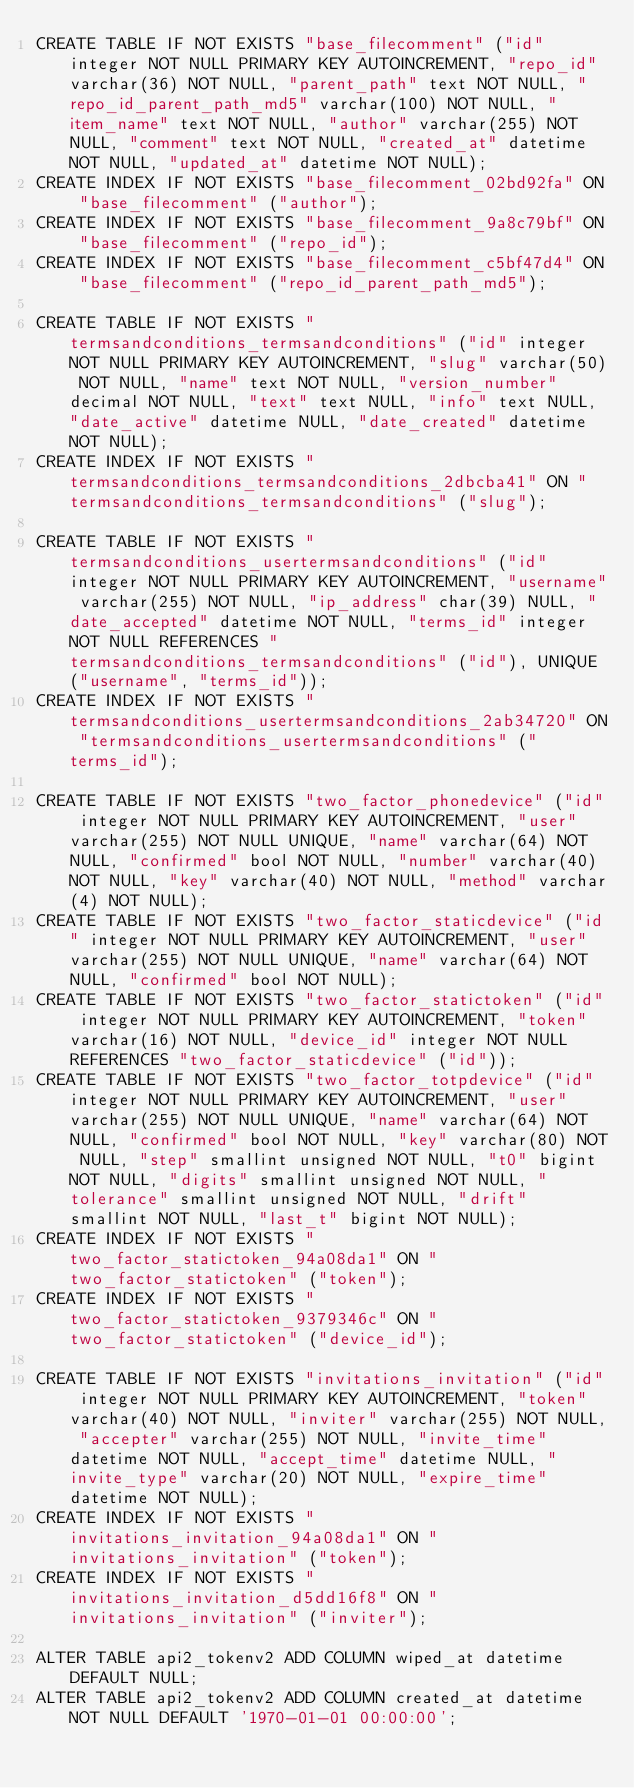Convert code to text. <code><loc_0><loc_0><loc_500><loc_500><_SQL_>CREATE TABLE IF NOT EXISTS "base_filecomment" ("id" integer NOT NULL PRIMARY KEY AUTOINCREMENT, "repo_id" varchar(36) NOT NULL, "parent_path" text NOT NULL, "repo_id_parent_path_md5" varchar(100) NOT NULL, "item_name" text NOT NULL, "author" varchar(255) NOT NULL, "comment" text NOT NULL, "created_at" datetime NOT NULL, "updated_at" datetime NOT NULL);
CREATE INDEX IF NOT EXISTS "base_filecomment_02bd92fa" ON "base_filecomment" ("author");
CREATE INDEX IF NOT EXISTS "base_filecomment_9a8c79bf" ON "base_filecomment" ("repo_id");
CREATE INDEX IF NOT EXISTS "base_filecomment_c5bf47d4" ON "base_filecomment" ("repo_id_parent_path_md5");

CREATE TABLE IF NOT EXISTS "termsandconditions_termsandconditions" ("id" integer NOT NULL PRIMARY KEY AUTOINCREMENT, "slug" varchar(50) NOT NULL, "name" text NOT NULL, "version_number" decimal NOT NULL, "text" text NULL, "info" text NULL, "date_active" datetime NULL, "date_created" datetime NOT NULL);
CREATE INDEX IF NOT EXISTS "termsandconditions_termsandconditions_2dbcba41" ON "termsandconditions_termsandconditions" ("slug");

CREATE TABLE IF NOT EXISTS "termsandconditions_usertermsandconditions" ("id" integer NOT NULL PRIMARY KEY AUTOINCREMENT, "username" varchar(255) NOT NULL, "ip_address" char(39) NULL, "date_accepted" datetime NOT NULL, "terms_id" integer NOT NULL REFERENCES "termsandconditions_termsandconditions" ("id"), UNIQUE ("username", "terms_id"));
CREATE INDEX IF NOT EXISTS "termsandconditions_usertermsandconditions_2ab34720" ON "termsandconditions_usertermsandconditions" ("terms_id");

CREATE TABLE IF NOT EXISTS "two_factor_phonedevice" ("id" integer NOT NULL PRIMARY KEY AUTOINCREMENT, "user" varchar(255) NOT NULL UNIQUE, "name" varchar(64) NOT NULL, "confirmed" bool NOT NULL, "number" varchar(40) NOT NULL, "key" varchar(40) NOT NULL, "method" varchar(4) NOT NULL);
CREATE TABLE IF NOT EXISTS "two_factor_staticdevice" ("id" integer NOT NULL PRIMARY KEY AUTOINCREMENT, "user" varchar(255) NOT NULL UNIQUE, "name" varchar(64) NOT NULL, "confirmed" bool NOT NULL);
CREATE TABLE IF NOT EXISTS "two_factor_statictoken" ("id" integer NOT NULL PRIMARY KEY AUTOINCREMENT, "token" varchar(16) NOT NULL, "device_id" integer NOT NULL REFERENCES "two_factor_staticdevice" ("id"));
CREATE TABLE IF NOT EXISTS "two_factor_totpdevice" ("id" integer NOT NULL PRIMARY KEY AUTOINCREMENT, "user" varchar(255) NOT NULL UNIQUE, "name" varchar(64) NOT NULL, "confirmed" bool NOT NULL, "key" varchar(80) NOT NULL, "step" smallint unsigned NOT NULL, "t0" bigint NOT NULL, "digits" smallint unsigned NOT NULL, "tolerance" smallint unsigned NOT NULL, "drift" smallint NOT NULL, "last_t" bigint NOT NULL);
CREATE INDEX IF NOT EXISTS "two_factor_statictoken_94a08da1" ON "two_factor_statictoken" ("token");
CREATE INDEX IF NOT EXISTS "two_factor_statictoken_9379346c" ON "two_factor_statictoken" ("device_id");

CREATE TABLE IF NOT EXISTS "invitations_invitation" ("id" integer NOT NULL PRIMARY KEY AUTOINCREMENT, "token" varchar(40) NOT NULL, "inviter" varchar(255) NOT NULL, "accepter" varchar(255) NOT NULL, "invite_time" datetime NOT NULL, "accept_time" datetime NULL, "invite_type" varchar(20) NOT NULL, "expire_time" datetime NOT NULL);
CREATE INDEX IF NOT EXISTS "invitations_invitation_94a08da1" ON "invitations_invitation" ("token");
CREATE INDEX IF NOT EXISTS "invitations_invitation_d5dd16f8" ON "invitations_invitation" ("inviter");

ALTER TABLE api2_tokenv2 ADD COLUMN wiped_at datetime DEFAULT NULL;
ALTER TABLE api2_tokenv2 ADD COLUMN created_at datetime NOT NULL DEFAULT '1970-01-01 00:00:00';
</code> 